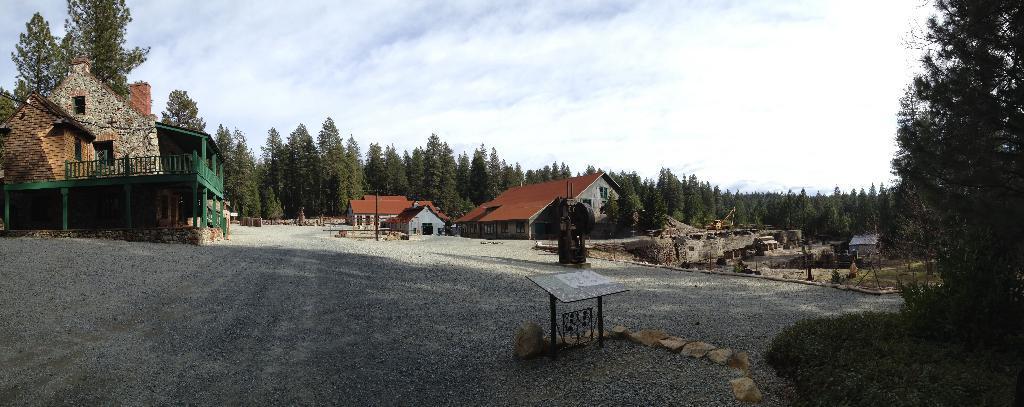Could you give a brief overview of what you see in this image? In the center of the image we can see a houses, trees, fencing, pole are present. At the bottom of the image ground is there. At the top of the image sky is present. In the middle we can see a table and rocks are present. At the bottom right corner grass is present. 